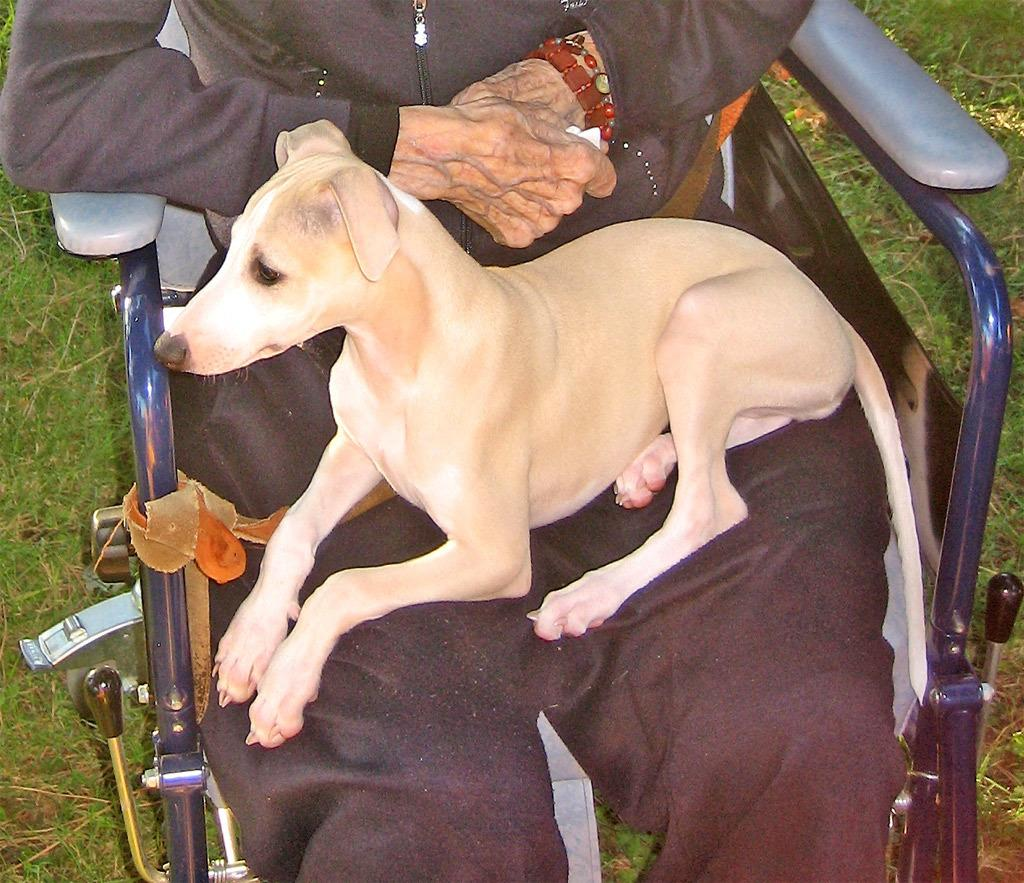What type of animal is in the image? There is a dog in the image. Where is the dog located? The dog is on a person. What is the person doing in the image? The person is sitting in a chair. What type of comb is the dog using to groom the person in the image? There is no comb present in the image, and the dog is not grooming the person. 